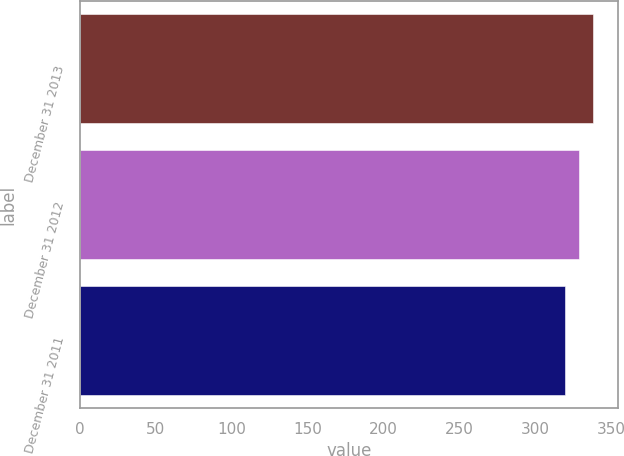<chart> <loc_0><loc_0><loc_500><loc_500><bar_chart><fcel>December 31 2013<fcel>December 31 2012<fcel>December 31 2011<nl><fcel>337.4<fcel>328.6<fcel>319.1<nl></chart> 